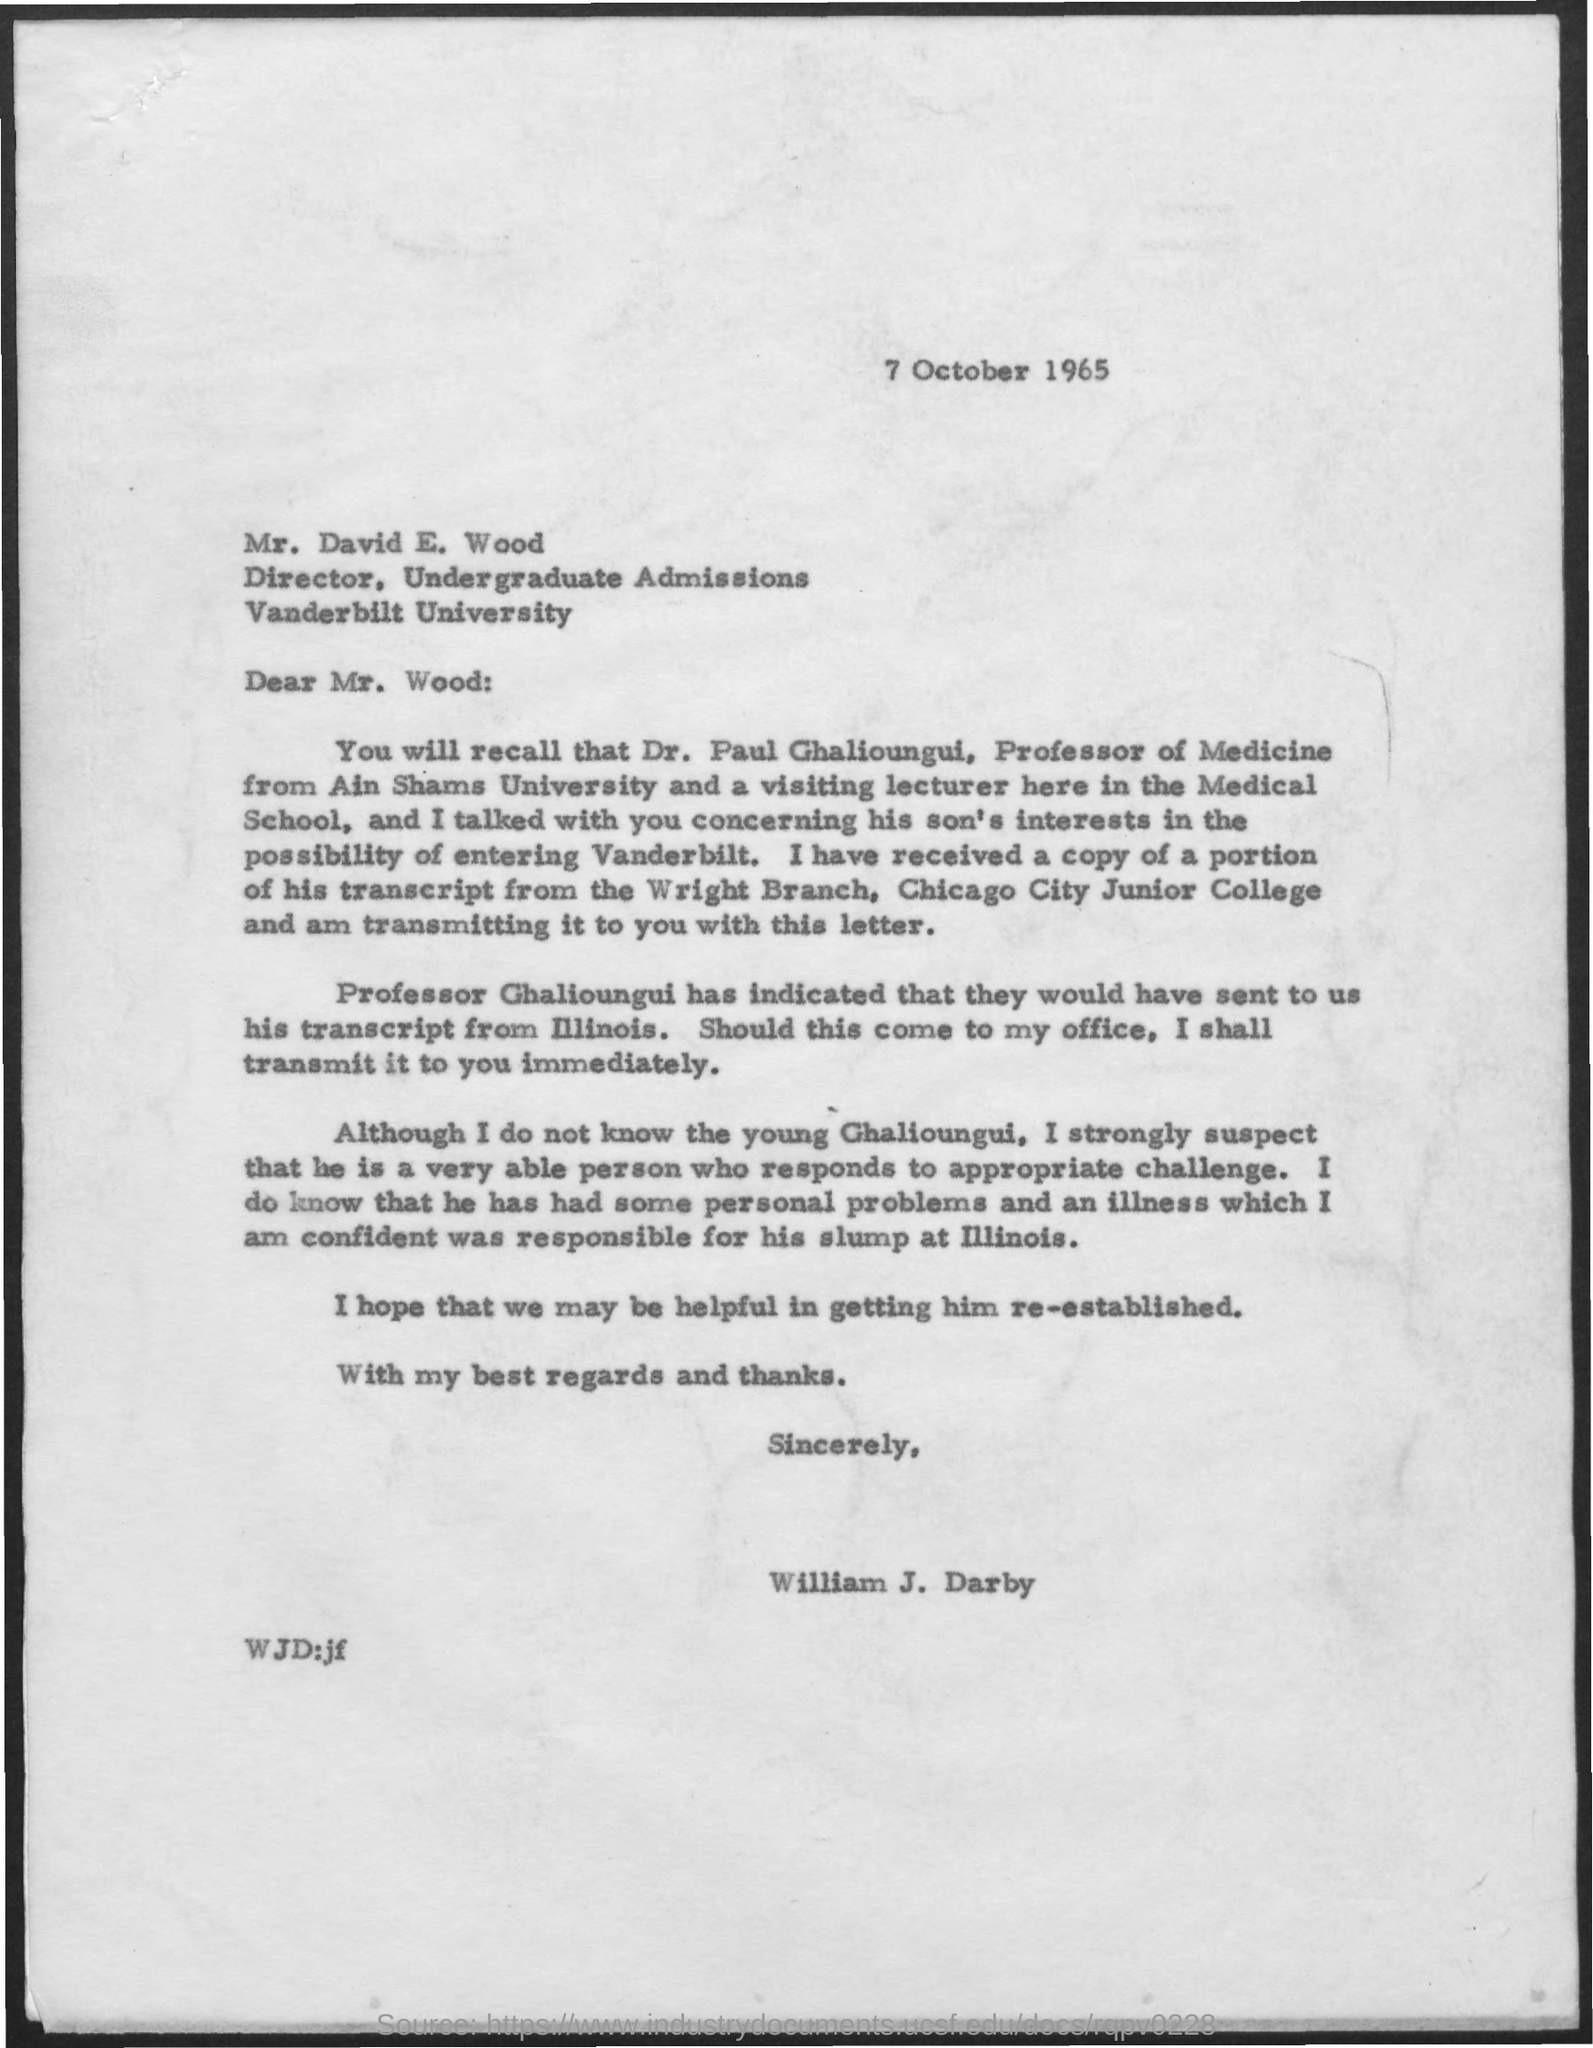When is the letter dated?
Keep it short and to the point. 7 October 1965. To whom is the letter addressed?
Give a very brief answer. Mr. David E. Wood. What is Mr. David's designation?
Ensure brevity in your answer.  Director. From whom is the letter?
Ensure brevity in your answer.  William J. Darby. 